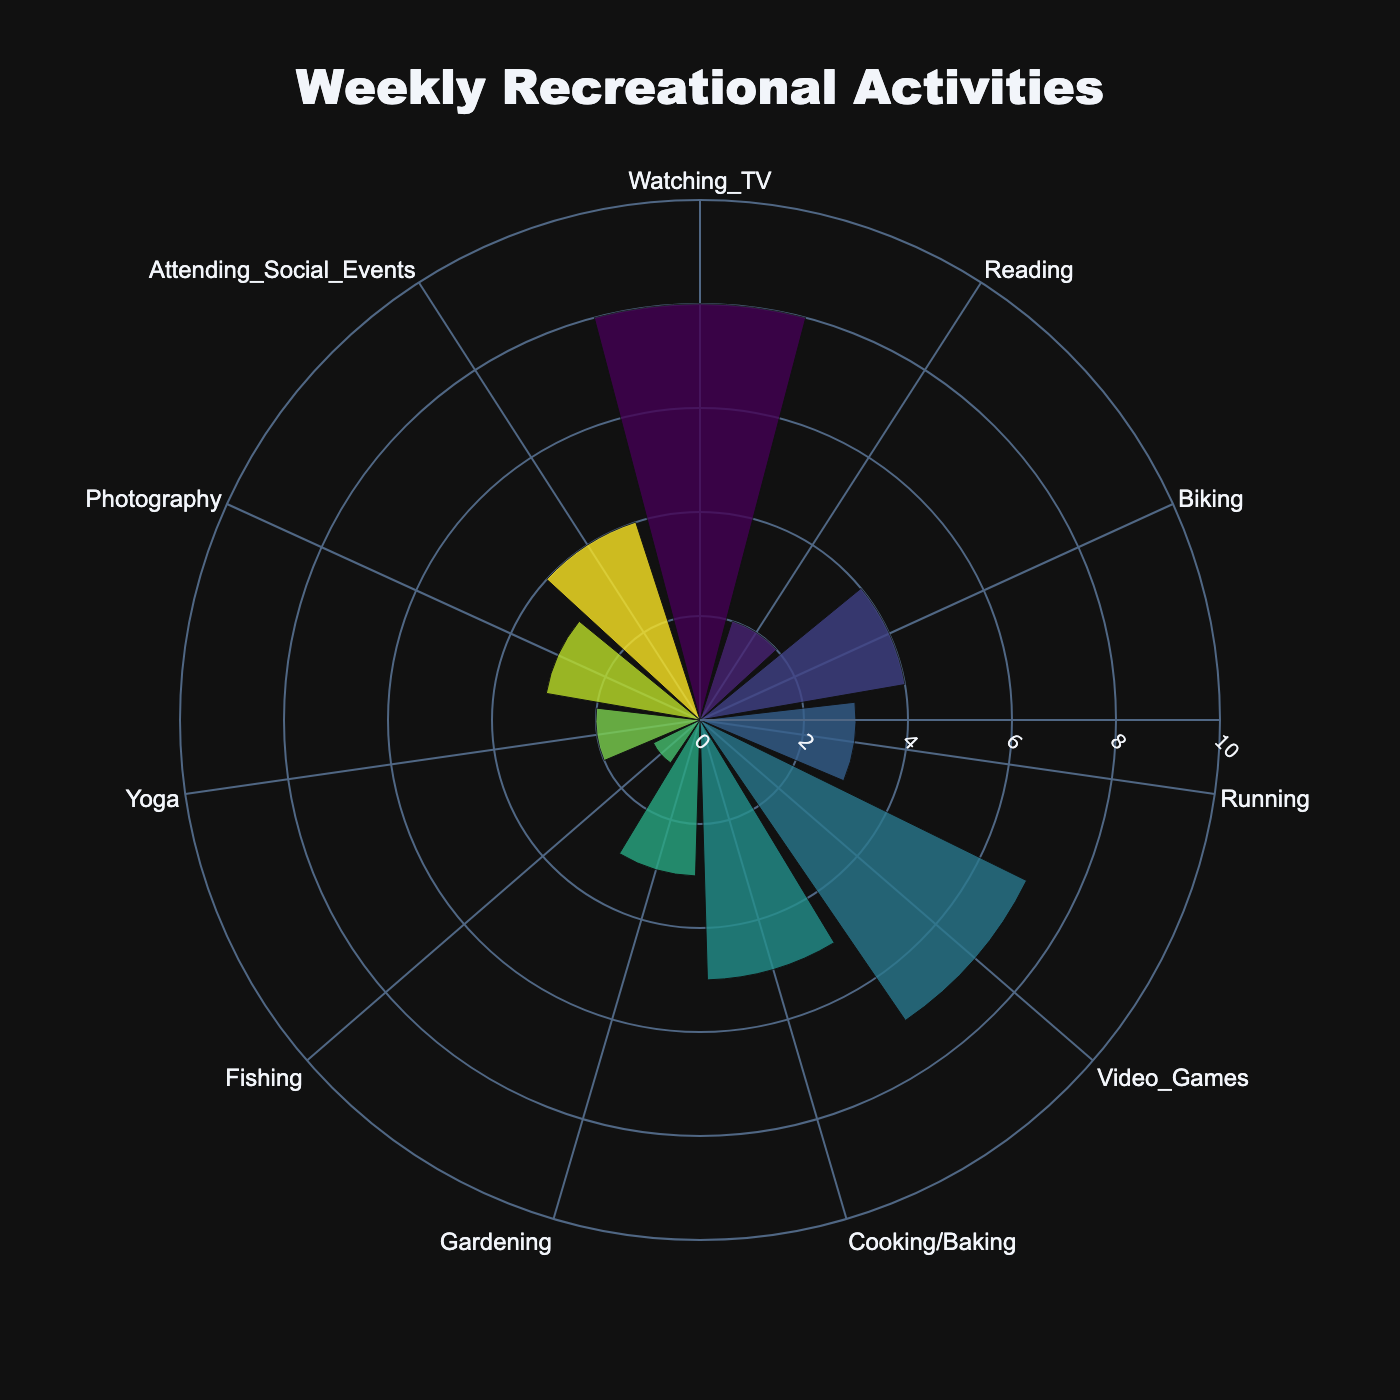What is the title of the chart? The title is usually displayed at the top of the chart, and in this case, it's set within the chart code.
Answer: Weekly Recreational Activities What is the activity with the highest number of hours spent? Identify which bar extends the furthest from the center, indicating the most hours spent.
Answer: Watching TV How many hours are spent on reading and yoga combined? Sum up the individual hours for reading and yoga. Reading is 2 hours, and yoga is 2 hours.
Answer: 4 hours Which activities have exactly 3 hours spent on them? Look for bars that reach the 3-hour mark and identify the corresponding activities.
Answer: Running, Gardening, Photography How many activities have more than 5 hours spent on them? Count the number of activities for which bars extend beyond the 5-hour mark.
Answer: 3 activities Which activity has the least hours spent per week? Identify the shortest bar in the chart, indicating the fewest hours.
Answer: Fishing What's the difference in hours spent between video games and cooking/baking? Subtract the hours for cooking/baking from the hours for video games. Video Games: 7 hours, Cooking/Baking: 5 hours.
Answer: 2 hours What is the average number of hours spent per activity? Add up all the hours spent and divide by the number of activities. Total hours = 42 hours. Number of activities = 11. Thus, 42 / 11 ≈ 3.82 hours
Answer: 3.82 hours Which activities have less than 4 hours spent per week? Identify bars that do not reach the 4-hour mark and list the activities.
Answer: Reading, Running, Gardening, Fishing, Yoga, Photography What is the total number of hours spent on physical activities (Biking, Running, Yoga)? Sum the hours spent on each physical activity: Biking (4 hours), Running (3 hours), Yoga (2 hours).
Answer: 9 hours 